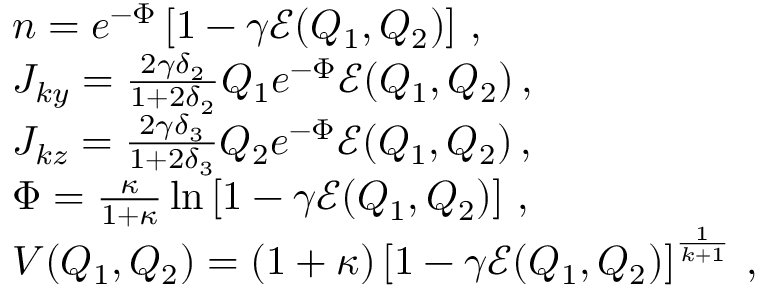Convert formula to latex. <formula><loc_0><loc_0><loc_500><loc_500>\begin{array} { r l } & { n = e ^ { - \Phi } \left [ 1 - \gamma { \mathcal { E } } ( Q _ { 1 } , Q _ { 2 } ) \right ] \, , } \\ & { J _ { k y } = \frac { 2 \gamma \delta _ { 2 } } { 1 + 2 \delta _ { 2 } } Q _ { 1 } e ^ { - \Phi } { \mathcal { E } } ( Q _ { 1 } , Q _ { 2 } ) \, , } \\ & { J _ { k z } = \frac { 2 \gamma \delta _ { 3 } } { 1 + 2 \delta _ { 3 } } Q _ { 2 } e ^ { - \Phi } { \mathcal { E } } ( Q _ { 1 } , Q _ { 2 } ) \, , } \\ & { \Phi = \frac { \kappa } { 1 + \kappa } \ln \left [ 1 - \gamma { \mathcal { E } } ( Q _ { 1 } , Q _ { 2 } ) \right ] \, , } \\ & { V ( Q _ { 1 } , Q _ { 2 } ) = ( 1 + \kappa ) \left [ 1 - \gamma { \mathcal { E } } ( Q _ { 1 } , Q _ { 2 } ) \right ] ^ { \frac { 1 } { k + 1 } } \, , } \end{array}</formula> 